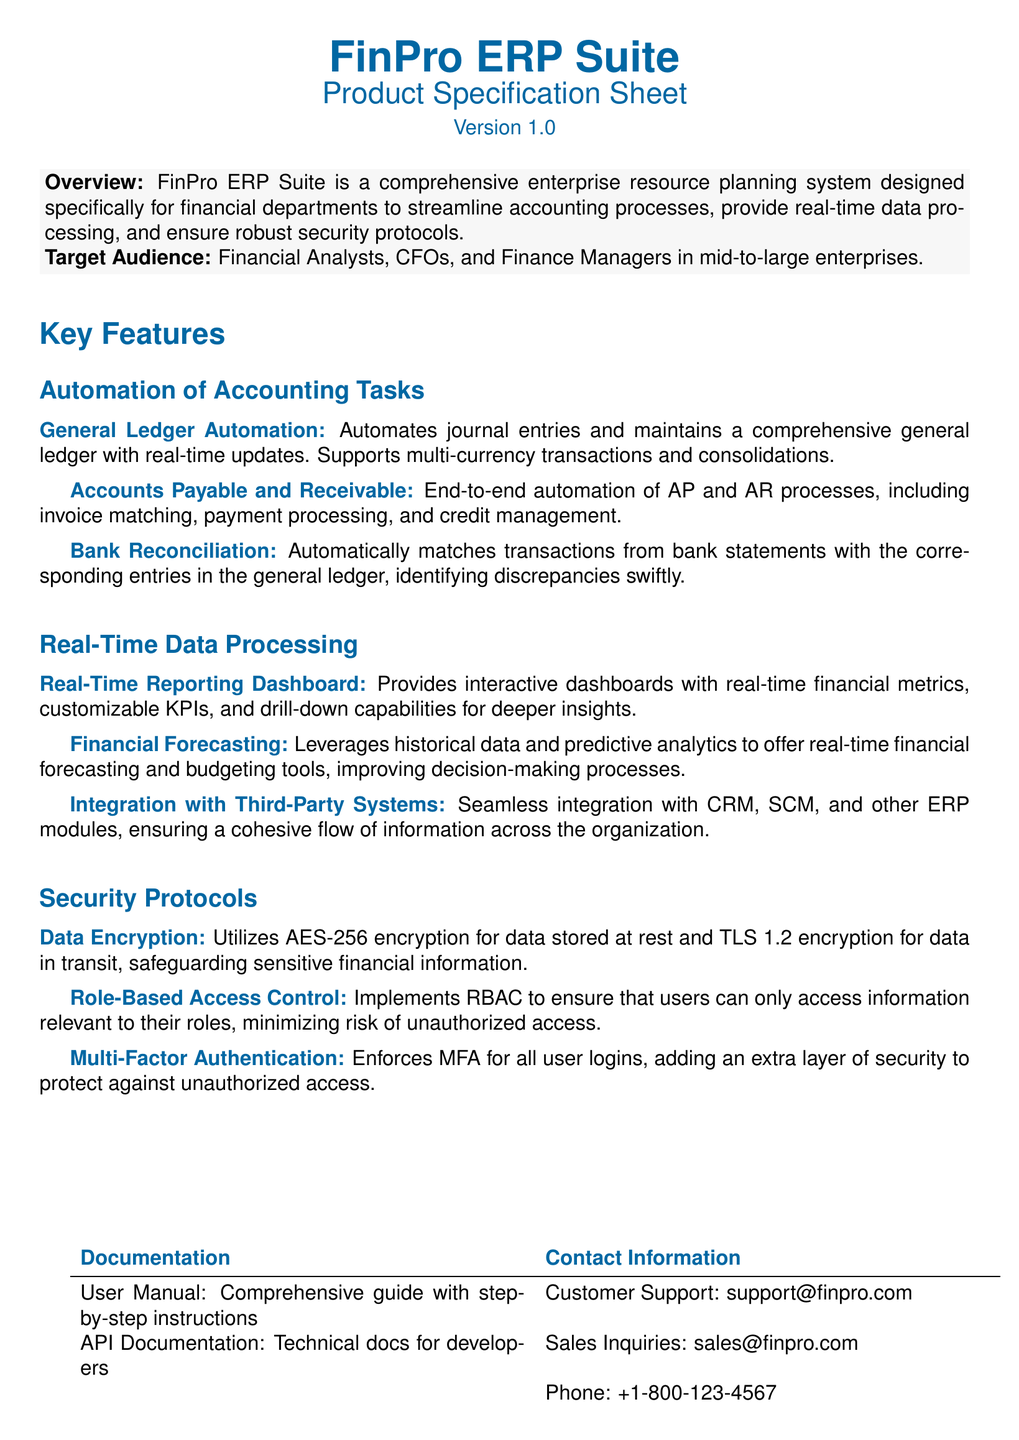What is the version of FinPro ERP Suite? The version of FinPro ERP Suite is mentioned in the document's title section.
Answer: Version 1.0 Who is the target audience for FinPro ERP Suite? The target audience is specified in the overview section of the document.
Answer: Financial Analysts, CFOs, and Finance Managers What encryption standard is used for data stored at rest? The document specifies the type of encryption used in the security protocols section for data stored at rest.
Answer: AES-256 How many features are listed under Automation of Accounting Tasks? The number of features is determined by counting the items listed in the respective subsection.
Answer: Three What type of access control is implemented to ensure user security? The document identifies the security measure related to access control.
Answer: Role-Based Access Control Which feature provides interactive dashboards? The feature that offers interactive dashboards can be found in the Real-Time Data Processing section.
Answer: Real-Time Reporting Dashboard What is the contact email for customer support? The document lists the contact information in a table, specifically for customer support inquiries.
Answer: support@finpro.com What type of authentication is enforced for all user logins? The specific security measure implemented for logins is mentioned in the security protocols section.
Answer: Multi-Factor Authentication 